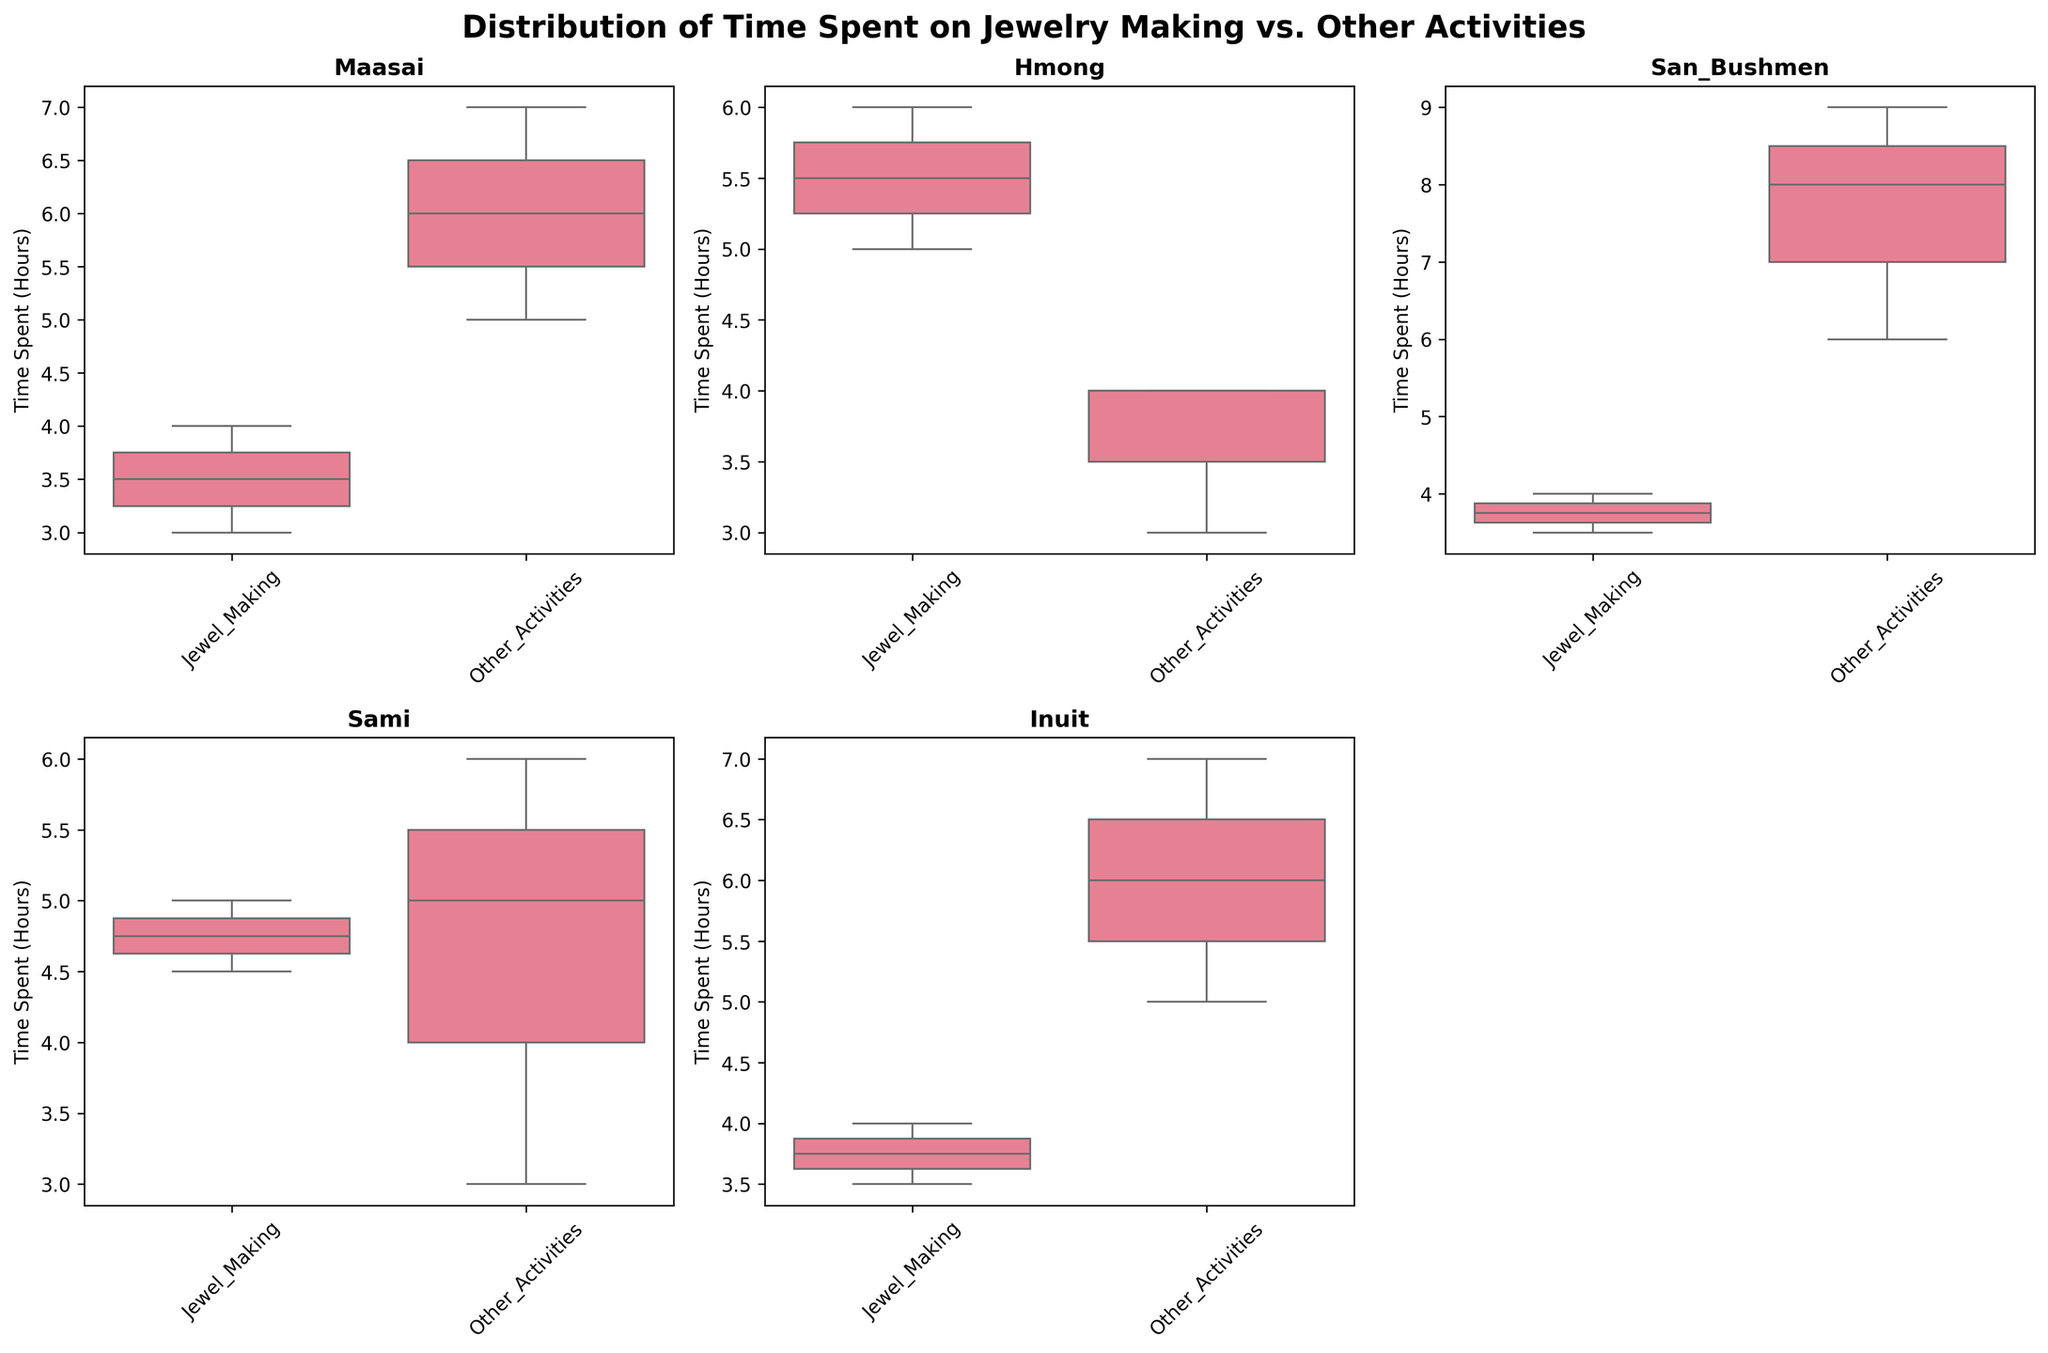Which community has the highest median time spent on other activities? By observing the median line within the box plot for each community’s “Other Activities”, we can see that the San Bushmen community has the highest line, indicating the highest median time spent on other activities.
Answer: San Bushmen What is the title of the entire figure? The title can be seen at the top of the figure, summarizing the overall context of the data visualized.
Answer: Distribution of Time Spent on Jewelry Making vs. Other Activities Which community shows the most consistency in time spent on jewelry making? Consistency can be gauged by the spread of the box plot. The narrower the box, the more consistent the data. The Sami community's box plot for "Jewel_Making" has the least spread, indicating high consistency.
Answer: Sami Does any community spend equal median time on both jewelry making and other activities? We need to compare the median lines of both activities for each community. The Sami community shows equal median times for both activities.
Answer: Sami Which activity has a higher median for the Maasai community? By comparing the median lines on the box plots for the Maasai community, it can be observed that "Other Activities" has a higher median.
Answer: Other Activities What is the range of time spent on other activities by the Inuit community? To find the range, we look at the minimum and maximum whisker endpoints for "Other Activities" for the Inuit community, which are 5 and 7, respectively. Therefore, the range is 7 - 5 = 2 hours.
Answer: 2 hours How many subplots are there in total? Count all subplots in the figure, including the removed one. There are five subplots (one for each community), plus an empty sixth space.
Answer: Six Which community appears to have the lowest variance in time spent on other activities? Variance is reflected in how spread out the whiskers and box lines are. The Hmong community’s box plot for "Other Activities" appears to be the narrowest, indicating the lowest variance.
Answer: Hmong In which activity (jewelry making or other activities) does the Hmong community spend more time on average? By examining the center (mean) and spread of both box plots for the Hmong community, it can be inferred that they spend slightly more average time on "Jewel_Making".
Answer: Jewelry Making Is there any community where the maximum time spent on jewelry making is higher than the minimum time spent on other activities? Observe the maximum whisker endpoint for "Jewel_Making" and compare it with the minimum whisker endpoint for "Other Activities". The Hmong community’s maximum time for jewelry making (6) is higher than their minimum time for other activities (3).
Answer: Hmong 